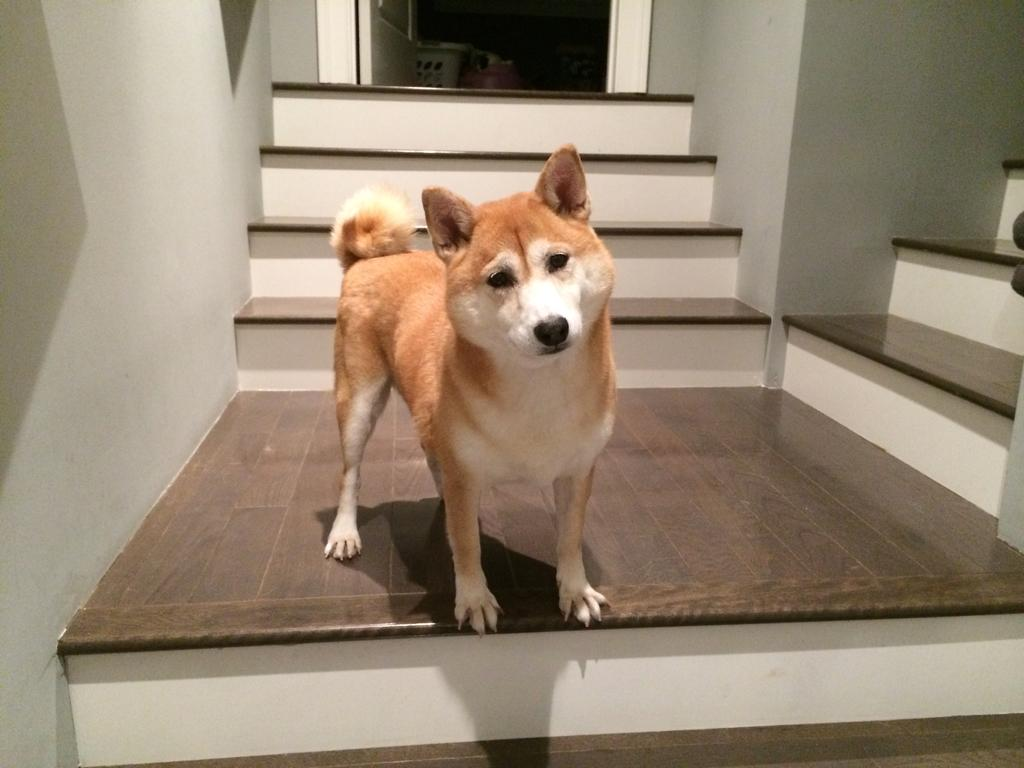What type of animal is in the image? There is a dog in the image. Can you describe the dog's appearance? The dog is brown and white in color. Where is the dog located in the image? The dog is standing on the stairs. What can be seen in the background of the image? There is a door visible in the background of the image. Is there a stream of water flowing near the dog in the image? No, there is no stream of water visible in the image. 